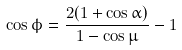<formula> <loc_0><loc_0><loc_500><loc_500>\cos \phi = \frac { 2 ( 1 + \cos \alpha ) } { 1 - \cos \mu } - 1</formula> 